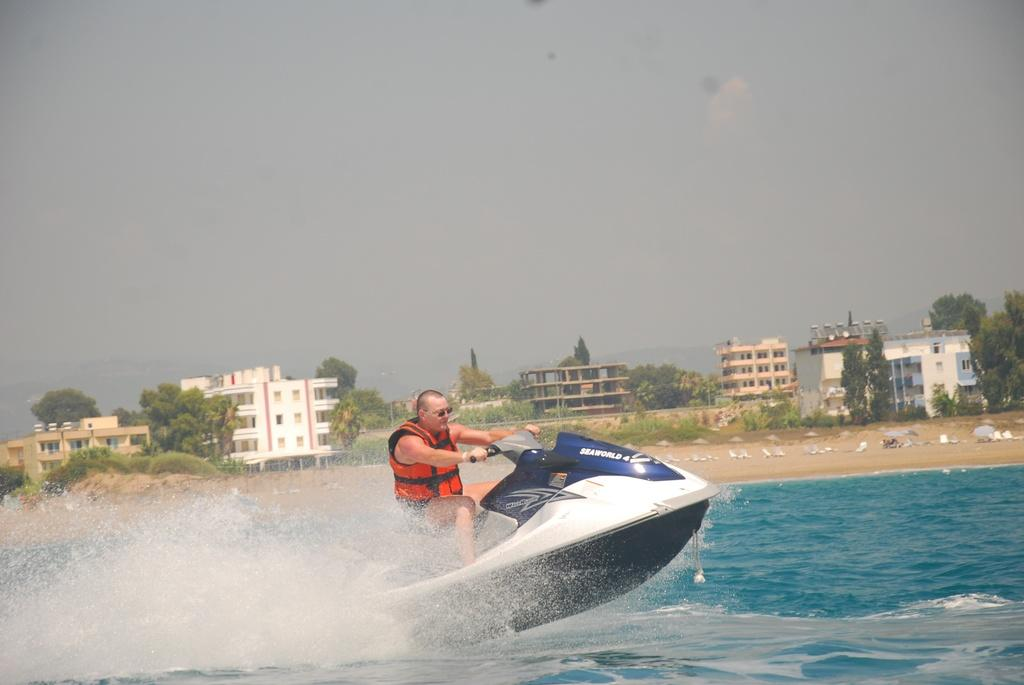Who is the person in the image? There is a man in the image. What is the man doing in the image? The man is surfing on a boat. Where is the boat located in the image? The boat is on the water. What can be seen in the background of the image? There are trees and buildings in the background of the image. What is the weather like in the image? The sky is cloudy in the image. How many rays can be seen coming from the sun in the image? There are no rays visible in the image. 